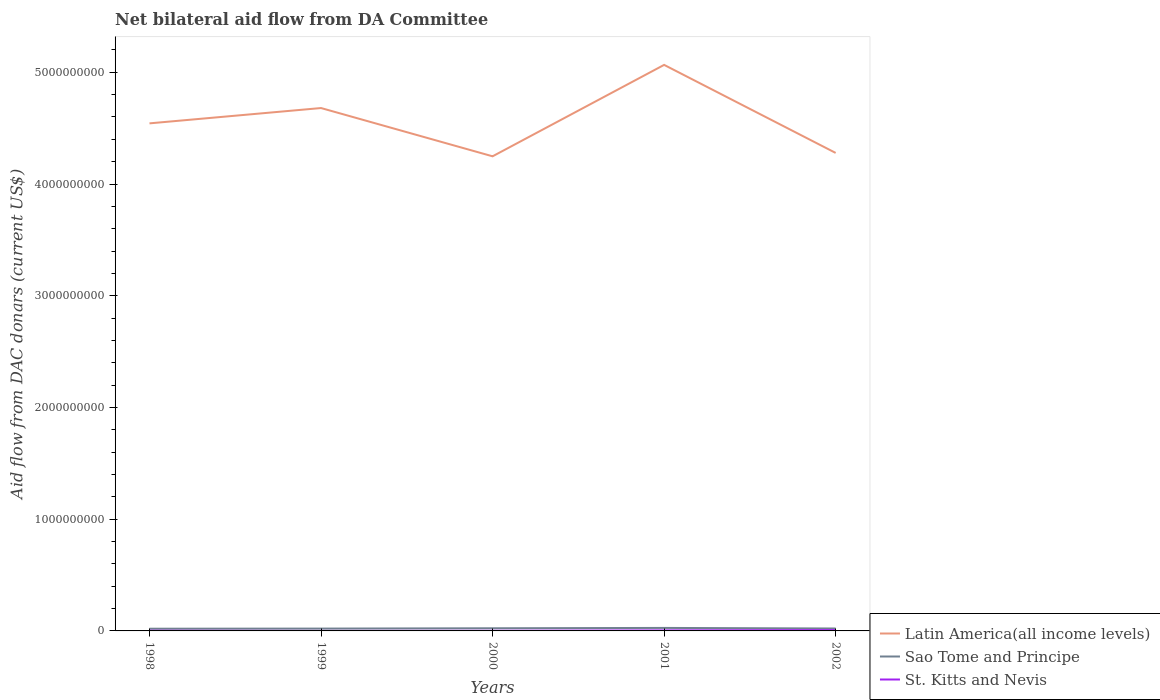How many different coloured lines are there?
Offer a very short reply. 3. Does the line corresponding to Sao Tome and Principe intersect with the line corresponding to Latin America(all income levels)?
Give a very brief answer. No. Is the number of lines equal to the number of legend labels?
Offer a terse response. Yes. Across all years, what is the maximum aid flow in in Latin America(all income levels)?
Provide a succinct answer. 4.25e+09. What is the total aid flow in in Latin America(all income levels) in the graph?
Your answer should be compact. -3.86e+08. What is the difference between the highest and the second highest aid flow in in Latin America(all income levels)?
Keep it short and to the point. 8.18e+08. How many years are there in the graph?
Provide a succinct answer. 5. What is the difference between two consecutive major ticks on the Y-axis?
Offer a terse response. 1.00e+09. Does the graph contain grids?
Provide a short and direct response. No. What is the title of the graph?
Ensure brevity in your answer.  Net bilateral aid flow from DA Committee. What is the label or title of the Y-axis?
Provide a short and direct response. Aid flow from DAC donars (current US$). What is the Aid flow from DAC donars (current US$) of Latin America(all income levels) in 1998?
Your answer should be compact. 4.54e+09. What is the Aid flow from DAC donars (current US$) of Sao Tome and Principe in 1998?
Provide a succinct answer. 1.98e+07. What is the Aid flow from DAC donars (current US$) in St. Kitts and Nevis in 1998?
Your response must be concise. 1.95e+06. What is the Aid flow from DAC donars (current US$) of Latin America(all income levels) in 1999?
Your answer should be very brief. 4.68e+09. What is the Aid flow from DAC donars (current US$) in Sao Tome and Principe in 1999?
Provide a short and direct response. 2.09e+07. What is the Aid flow from DAC donars (current US$) in St. Kitts and Nevis in 1999?
Offer a terse response. 1.70e+05. What is the Aid flow from DAC donars (current US$) of Latin America(all income levels) in 2000?
Your answer should be very brief. 4.25e+09. What is the Aid flow from DAC donars (current US$) of Sao Tome and Principe in 2000?
Ensure brevity in your answer.  2.37e+07. What is the Aid flow from DAC donars (current US$) of St. Kitts and Nevis in 2000?
Provide a succinct answer. 1.39e+06. What is the Aid flow from DAC donars (current US$) in Latin America(all income levels) in 2001?
Ensure brevity in your answer.  5.07e+09. What is the Aid flow from DAC donars (current US$) of Sao Tome and Principe in 2001?
Provide a short and direct response. 2.69e+07. What is the Aid flow from DAC donars (current US$) in St. Kitts and Nevis in 2001?
Ensure brevity in your answer.  4.81e+06. What is the Aid flow from DAC donars (current US$) of Latin America(all income levels) in 2002?
Provide a succinct answer. 4.28e+09. What is the Aid flow from DAC donars (current US$) in Sao Tome and Principe in 2002?
Provide a short and direct response. 2.16e+07. What is the Aid flow from DAC donars (current US$) of St. Kitts and Nevis in 2002?
Provide a short and direct response. 7.33e+06. Across all years, what is the maximum Aid flow from DAC donars (current US$) of Latin America(all income levels)?
Make the answer very short. 5.07e+09. Across all years, what is the maximum Aid flow from DAC donars (current US$) in Sao Tome and Principe?
Make the answer very short. 2.69e+07. Across all years, what is the maximum Aid flow from DAC donars (current US$) in St. Kitts and Nevis?
Ensure brevity in your answer.  7.33e+06. Across all years, what is the minimum Aid flow from DAC donars (current US$) of Latin America(all income levels)?
Keep it short and to the point. 4.25e+09. Across all years, what is the minimum Aid flow from DAC donars (current US$) in Sao Tome and Principe?
Offer a terse response. 1.98e+07. Across all years, what is the minimum Aid flow from DAC donars (current US$) in St. Kitts and Nevis?
Your answer should be compact. 1.70e+05. What is the total Aid flow from DAC donars (current US$) of Latin America(all income levels) in the graph?
Offer a terse response. 2.28e+1. What is the total Aid flow from DAC donars (current US$) in Sao Tome and Principe in the graph?
Your answer should be very brief. 1.13e+08. What is the total Aid flow from DAC donars (current US$) in St. Kitts and Nevis in the graph?
Make the answer very short. 1.56e+07. What is the difference between the Aid flow from DAC donars (current US$) of Latin America(all income levels) in 1998 and that in 1999?
Give a very brief answer. -1.37e+08. What is the difference between the Aid flow from DAC donars (current US$) of Sao Tome and Principe in 1998 and that in 1999?
Your response must be concise. -1.09e+06. What is the difference between the Aid flow from DAC donars (current US$) of St. Kitts and Nevis in 1998 and that in 1999?
Provide a short and direct response. 1.78e+06. What is the difference between the Aid flow from DAC donars (current US$) of Latin America(all income levels) in 1998 and that in 2000?
Provide a succinct answer. 2.95e+08. What is the difference between the Aid flow from DAC donars (current US$) of Sao Tome and Principe in 1998 and that in 2000?
Provide a short and direct response. -3.93e+06. What is the difference between the Aid flow from DAC donars (current US$) in St. Kitts and Nevis in 1998 and that in 2000?
Make the answer very short. 5.60e+05. What is the difference between the Aid flow from DAC donars (current US$) in Latin America(all income levels) in 1998 and that in 2001?
Your answer should be compact. -5.23e+08. What is the difference between the Aid flow from DAC donars (current US$) of Sao Tome and Principe in 1998 and that in 2001?
Ensure brevity in your answer.  -7.11e+06. What is the difference between the Aid flow from DAC donars (current US$) in St. Kitts and Nevis in 1998 and that in 2001?
Give a very brief answer. -2.86e+06. What is the difference between the Aid flow from DAC donars (current US$) in Latin America(all income levels) in 1998 and that in 2002?
Offer a terse response. 2.65e+08. What is the difference between the Aid flow from DAC donars (current US$) of Sao Tome and Principe in 1998 and that in 2002?
Give a very brief answer. -1.86e+06. What is the difference between the Aid flow from DAC donars (current US$) of St. Kitts and Nevis in 1998 and that in 2002?
Provide a short and direct response. -5.38e+06. What is the difference between the Aid flow from DAC donars (current US$) of Latin America(all income levels) in 1999 and that in 2000?
Provide a succinct answer. 4.32e+08. What is the difference between the Aid flow from DAC donars (current US$) in Sao Tome and Principe in 1999 and that in 2000?
Make the answer very short. -2.84e+06. What is the difference between the Aid flow from DAC donars (current US$) in St. Kitts and Nevis in 1999 and that in 2000?
Offer a very short reply. -1.22e+06. What is the difference between the Aid flow from DAC donars (current US$) in Latin America(all income levels) in 1999 and that in 2001?
Give a very brief answer. -3.86e+08. What is the difference between the Aid flow from DAC donars (current US$) in Sao Tome and Principe in 1999 and that in 2001?
Your response must be concise. -6.02e+06. What is the difference between the Aid flow from DAC donars (current US$) of St. Kitts and Nevis in 1999 and that in 2001?
Ensure brevity in your answer.  -4.64e+06. What is the difference between the Aid flow from DAC donars (current US$) in Latin America(all income levels) in 1999 and that in 2002?
Ensure brevity in your answer.  4.02e+08. What is the difference between the Aid flow from DAC donars (current US$) in Sao Tome and Principe in 1999 and that in 2002?
Your answer should be very brief. -7.70e+05. What is the difference between the Aid flow from DAC donars (current US$) of St. Kitts and Nevis in 1999 and that in 2002?
Make the answer very short. -7.16e+06. What is the difference between the Aid flow from DAC donars (current US$) in Latin America(all income levels) in 2000 and that in 2001?
Give a very brief answer. -8.18e+08. What is the difference between the Aid flow from DAC donars (current US$) of Sao Tome and Principe in 2000 and that in 2001?
Offer a very short reply. -3.18e+06. What is the difference between the Aid flow from DAC donars (current US$) of St. Kitts and Nevis in 2000 and that in 2001?
Give a very brief answer. -3.42e+06. What is the difference between the Aid flow from DAC donars (current US$) in Latin America(all income levels) in 2000 and that in 2002?
Offer a very short reply. -3.03e+07. What is the difference between the Aid flow from DAC donars (current US$) of Sao Tome and Principe in 2000 and that in 2002?
Your answer should be compact. 2.07e+06. What is the difference between the Aid flow from DAC donars (current US$) of St. Kitts and Nevis in 2000 and that in 2002?
Keep it short and to the point. -5.94e+06. What is the difference between the Aid flow from DAC donars (current US$) of Latin America(all income levels) in 2001 and that in 2002?
Provide a short and direct response. 7.88e+08. What is the difference between the Aid flow from DAC donars (current US$) of Sao Tome and Principe in 2001 and that in 2002?
Provide a short and direct response. 5.25e+06. What is the difference between the Aid flow from DAC donars (current US$) of St. Kitts and Nevis in 2001 and that in 2002?
Your answer should be very brief. -2.52e+06. What is the difference between the Aid flow from DAC donars (current US$) of Latin America(all income levels) in 1998 and the Aid flow from DAC donars (current US$) of Sao Tome and Principe in 1999?
Provide a short and direct response. 4.52e+09. What is the difference between the Aid flow from DAC donars (current US$) in Latin America(all income levels) in 1998 and the Aid flow from DAC donars (current US$) in St. Kitts and Nevis in 1999?
Ensure brevity in your answer.  4.54e+09. What is the difference between the Aid flow from DAC donars (current US$) of Sao Tome and Principe in 1998 and the Aid flow from DAC donars (current US$) of St. Kitts and Nevis in 1999?
Ensure brevity in your answer.  1.96e+07. What is the difference between the Aid flow from DAC donars (current US$) in Latin America(all income levels) in 1998 and the Aid flow from DAC donars (current US$) in Sao Tome and Principe in 2000?
Your answer should be compact. 4.52e+09. What is the difference between the Aid flow from DAC donars (current US$) in Latin America(all income levels) in 1998 and the Aid flow from DAC donars (current US$) in St. Kitts and Nevis in 2000?
Make the answer very short. 4.54e+09. What is the difference between the Aid flow from DAC donars (current US$) in Sao Tome and Principe in 1998 and the Aid flow from DAC donars (current US$) in St. Kitts and Nevis in 2000?
Your answer should be compact. 1.84e+07. What is the difference between the Aid flow from DAC donars (current US$) of Latin America(all income levels) in 1998 and the Aid flow from DAC donars (current US$) of Sao Tome and Principe in 2001?
Give a very brief answer. 4.52e+09. What is the difference between the Aid flow from DAC donars (current US$) in Latin America(all income levels) in 1998 and the Aid flow from DAC donars (current US$) in St. Kitts and Nevis in 2001?
Offer a terse response. 4.54e+09. What is the difference between the Aid flow from DAC donars (current US$) in Sao Tome and Principe in 1998 and the Aid flow from DAC donars (current US$) in St. Kitts and Nevis in 2001?
Provide a succinct answer. 1.50e+07. What is the difference between the Aid flow from DAC donars (current US$) of Latin America(all income levels) in 1998 and the Aid flow from DAC donars (current US$) of Sao Tome and Principe in 2002?
Offer a terse response. 4.52e+09. What is the difference between the Aid flow from DAC donars (current US$) of Latin America(all income levels) in 1998 and the Aid flow from DAC donars (current US$) of St. Kitts and Nevis in 2002?
Provide a short and direct response. 4.54e+09. What is the difference between the Aid flow from DAC donars (current US$) in Sao Tome and Principe in 1998 and the Aid flow from DAC donars (current US$) in St. Kitts and Nevis in 2002?
Provide a short and direct response. 1.24e+07. What is the difference between the Aid flow from DAC donars (current US$) in Latin America(all income levels) in 1999 and the Aid flow from DAC donars (current US$) in Sao Tome and Principe in 2000?
Give a very brief answer. 4.66e+09. What is the difference between the Aid flow from DAC donars (current US$) of Latin America(all income levels) in 1999 and the Aid flow from DAC donars (current US$) of St. Kitts and Nevis in 2000?
Make the answer very short. 4.68e+09. What is the difference between the Aid flow from DAC donars (current US$) of Sao Tome and Principe in 1999 and the Aid flow from DAC donars (current US$) of St. Kitts and Nevis in 2000?
Offer a very short reply. 1.95e+07. What is the difference between the Aid flow from DAC donars (current US$) of Latin America(all income levels) in 1999 and the Aid flow from DAC donars (current US$) of Sao Tome and Principe in 2001?
Your answer should be very brief. 4.65e+09. What is the difference between the Aid flow from DAC donars (current US$) of Latin America(all income levels) in 1999 and the Aid flow from DAC donars (current US$) of St. Kitts and Nevis in 2001?
Offer a very short reply. 4.68e+09. What is the difference between the Aid flow from DAC donars (current US$) of Sao Tome and Principe in 1999 and the Aid flow from DAC donars (current US$) of St. Kitts and Nevis in 2001?
Your response must be concise. 1.61e+07. What is the difference between the Aid flow from DAC donars (current US$) in Latin America(all income levels) in 1999 and the Aid flow from DAC donars (current US$) in Sao Tome and Principe in 2002?
Provide a succinct answer. 4.66e+09. What is the difference between the Aid flow from DAC donars (current US$) of Latin America(all income levels) in 1999 and the Aid flow from DAC donars (current US$) of St. Kitts and Nevis in 2002?
Offer a very short reply. 4.67e+09. What is the difference between the Aid flow from DAC donars (current US$) of Sao Tome and Principe in 1999 and the Aid flow from DAC donars (current US$) of St. Kitts and Nevis in 2002?
Provide a succinct answer. 1.35e+07. What is the difference between the Aid flow from DAC donars (current US$) in Latin America(all income levels) in 2000 and the Aid flow from DAC donars (current US$) in Sao Tome and Principe in 2001?
Keep it short and to the point. 4.22e+09. What is the difference between the Aid flow from DAC donars (current US$) in Latin America(all income levels) in 2000 and the Aid flow from DAC donars (current US$) in St. Kitts and Nevis in 2001?
Your response must be concise. 4.24e+09. What is the difference between the Aid flow from DAC donars (current US$) in Sao Tome and Principe in 2000 and the Aid flow from DAC donars (current US$) in St. Kitts and Nevis in 2001?
Make the answer very short. 1.89e+07. What is the difference between the Aid flow from DAC donars (current US$) of Latin America(all income levels) in 2000 and the Aid flow from DAC donars (current US$) of Sao Tome and Principe in 2002?
Make the answer very short. 4.23e+09. What is the difference between the Aid flow from DAC donars (current US$) of Latin America(all income levels) in 2000 and the Aid flow from DAC donars (current US$) of St. Kitts and Nevis in 2002?
Offer a terse response. 4.24e+09. What is the difference between the Aid flow from DAC donars (current US$) of Sao Tome and Principe in 2000 and the Aid flow from DAC donars (current US$) of St. Kitts and Nevis in 2002?
Your answer should be compact. 1.64e+07. What is the difference between the Aid flow from DAC donars (current US$) of Latin America(all income levels) in 2001 and the Aid flow from DAC donars (current US$) of Sao Tome and Principe in 2002?
Your answer should be compact. 5.04e+09. What is the difference between the Aid flow from DAC donars (current US$) in Latin America(all income levels) in 2001 and the Aid flow from DAC donars (current US$) in St. Kitts and Nevis in 2002?
Your response must be concise. 5.06e+09. What is the difference between the Aid flow from DAC donars (current US$) in Sao Tome and Principe in 2001 and the Aid flow from DAC donars (current US$) in St. Kitts and Nevis in 2002?
Keep it short and to the point. 1.96e+07. What is the average Aid flow from DAC donars (current US$) of Latin America(all income levels) per year?
Your answer should be very brief. 4.56e+09. What is the average Aid flow from DAC donars (current US$) of Sao Tome and Principe per year?
Ensure brevity in your answer.  2.26e+07. What is the average Aid flow from DAC donars (current US$) in St. Kitts and Nevis per year?
Ensure brevity in your answer.  3.13e+06. In the year 1998, what is the difference between the Aid flow from DAC donars (current US$) in Latin America(all income levels) and Aid flow from DAC donars (current US$) in Sao Tome and Principe?
Ensure brevity in your answer.  4.52e+09. In the year 1998, what is the difference between the Aid flow from DAC donars (current US$) in Latin America(all income levels) and Aid flow from DAC donars (current US$) in St. Kitts and Nevis?
Keep it short and to the point. 4.54e+09. In the year 1998, what is the difference between the Aid flow from DAC donars (current US$) of Sao Tome and Principe and Aid flow from DAC donars (current US$) of St. Kitts and Nevis?
Provide a succinct answer. 1.78e+07. In the year 1999, what is the difference between the Aid flow from DAC donars (current US$) in Latin America(all income levels) and Aid flow from DAC donars (current US$) in Sao Tome and Principe?
Offer a terse response. 4.66e+09. In the year 1999, what is the difference between the Aid flow from DAC donars (current US$) of Latin America(all income levels) and Aid flow from DAC donars (current US$) of St. Kitts and Nevis?
Provide a short and direct response. 4.68e+09. In the year 1999, what is the difference between the Aid flow from DAC donars (current US$) of Sao Tome and Principe and Aid flow from DAC donars (current US$) of St. Kitts and Nevis?
Offer a very short reply. 2.07e+07. In the year 2000, what is the difference between the Aid flow from DAC donars (current US$) of Latin America(all income levels) and Aid flow from DAC donars (current US$) of Sao Tome and Principe?
Your response must be concise. 4.22e+09. In the year 2000, what is the difference between the Aid flow from DAC donars (current US$) of Latin America(all income levels) and Aid flow from DAC donars (current US$) of St. Kitts and Nevis?
Your answer should be compact. 4.25e+09. In the year 2000, what is the difference between the Aid flow from DAC donars (current US$) of Sao Tome and Principe and Aid flow from DAC donars (current US$) of St. Kitts and Nevis?
Ensure brevity in your answer.  2.23e+07. In the year 2001, what is the difference between the Aid flow from DAC donars (current US$) of Latin America(all income levels) and Aid flow from DAC donars (current US$) of Sao Tome and Principe?
Your response must be concise. 5.04e+09. In the year 2001, what is the difference between the Aid flow from DAC donars (current US$) in Latin America(all income levels) and Aid flow from DAC donars (current US$) in St. Kitts and Nevis?
Provide a short and direct response. 5.06e+09. In the year 2001, what is the difference between the Aid flow from DAC donars (current US$) in Sao Tome and Principe and Aid flow from DAC donars (current US$) in St. Kitts and Nevis?
Give a very brief answer. 2.21e+07. In the year 2002, what is the difference between the Aid flow from DAC donars (current US$) in Latin America(all income levels) and Aid flow from DAC donars (current US$) in Sao Tome and Principe?
Your answer should be very brief. 4.26e+09. In the year 2002, what is the difference between the Aid flow from DAC donars (current US$) of Latin America(all income levels) and Aid flow from DAC donars (current US$) of St. Kitts and Nevis?
Your response must be concise. 4.27e+09. In the year 2002, what is the difference between the Aid flow from DAC donars (current US$) of Sao Tome and Principe and Aid flow from DAC donars (current US$) of St. Kitts and Nevis?
Your answer should be compact. 1.43e+07. What is the ratio of the Aid flow from DAC donars (current US$) of Latin America(all income levels) in 1998 to that in 1999?
Your response must be concise. 0.97. What is the ratio of the Aid flow from DAC donars (current US$) in Sao Tome and Principe in 1998 to that in 1999?
Offer a very short reply. 0.95. What is the ratio of the Aid flow from DAC donars (current US$) in St. Kitts and Nevis in 1998 to that in 1999?
Offer a terse response. 11.47. What is the ratio of the Aid flow from DAC donars (current US$) of Latin America(all income levels) in 1998 to that in 2000?
Offer a very short reply. 1.07. What is the ratio of the Aid flow from DAC donars (current US$) of Sao Tome and Principe in 1998 to that in 2000?
Offer a terse response. 0.83. What is the ratio of the Aid flow from DAC donars (current US$) of St. Kitts and Nevis in 1998 to that in 2000?
Offer a very short reply. 1.4. What is the ratio of the Aid flow from DAC donars (current US$) in Latin America(all income levels) in 1998 to that in 2001?
Keep it short and to the point. 0.9. What is the ratio of the Aid flow from DAC donars (current US$) in Sao Tome and Principe in 1998 to that in 2001?
Keep it short and to the point. 0.74. What is the ratio of the Aid flow from DAC donars (current US$) in St. Kitts and Nevis in 1998 to that in 2001?
Offer a very short reply. 0.41. What is the ratio of the Aid flow from DAC donars (current US$) of Latin America(all income levels) in 1998 to that in 2002?
Make the answer very short. 1.06. What is the ratio of the Aid flow from DAC donars (current US$) in Sao Tome and Principe in 1998 to that in 2002?
Make the answer very short. 0.91. What is the ratio of the Aid flow from DAC donars (current US$) in St. Kitts and Nevis in 1998 to that in 2002?
Keep it short and to the point. 0.27. What is the ratio of the Aid flow from DAC donars (current US$) in Latin America(all income levels) in 1999 to that in 2000?
Your answer should be compact. 1.1. What is the ratio of the Aid flow from DAC donars (current US$) of Sao Tome and Principe in 1999 to that in 2000?
Your answer should be very brief. 0.88. What is the ratio of the Aid flow from DAC donars (current US$) of St. Kitts and Nevis in 1999 to that in 2000?
Offer a terse response. 0.12. What is the ratio of the Aid flow from DAC donars (current US$) in Latin America(all income levels) in 1999 to that in 2001?
Offer a terse response. 0.92. What is the ratio of the Aid flow from DAC donars (current US$) of Sao Tome and Principe in 1999 to that in 2001?
Offer a terse response. 0.78. What is the ratio of the Aid flow from DAC donars (current US$) in St. Kitts and Nevis in 1999 to that in 2001?
Offer a very short reply. 0.04. What is the ratio of the Aid flow from DAC donars (current US$) in Latin America(all income levels) in 1999 to that in 2002?
Offer a terse response. 1.09. What is the ratio of the Aid flow from DAC donars (current US$) of Sao Tome and Principe in 1999 to that in 2002?
Your answer should be compact. 0.96. What is the ratio of the Aid flow from DAC donars (current US$) of St. Kitts and Nevis in 1999 to that in 2002?
Make the answer very short. 0.02. What is the ratio of the Aid flow from DAC donars (current US$) in Latin America(all income levels) in 2000 to that in 2001?
Provide a short and direct response. 0.84. What is the ratio of the Aid flow from DAC donars (current US$) of Sao Tome and Principe in 2000 to that in 2001?
Offer a very short reply. 0.88. What is the ratio of the Aid flow from DAC donars (current US$) of St. Kitts and Nevis in 2000 to that in 2001?
Make the answer very short. 0.29. What is the ratio of the Aid flow from DAC donars (current US$) in Latin America(all income levels) in 2000 to that in 2002?
Ensure brevity in your answer.  0.99. What is the ratio of the Aid flow from DAC donars (current US$) of Sao Tome and Principe in 2000 to that in 2002?
Make the answer very short. 1.1. What is the ratio of the Aid flow from DAC donars (current US$) in St. Kitts and Nevis in 2000 to that in 2002?
Make the answer very short. 0.19. What is the ratio of the Aid flow from DAC donars (current US$) in Latin America(all income levels) in 2001 to that in 2002?
Keep it short and to the point. 1.18. What is the ratio of the Aid flow from DAC donars (current US$) in Sao Tome and Principe in 2001 to that in 2002?
Provide a short and direct response. 1.24. What is the ratio of the Aid flow from DAC donars (current US$) of St. Kitts and Nevis in 2001 to that in 2002?
Provide a short and direct response. 0.66. What is the difference between the highest and the second highest Aid flow from DAC donars (current US$) in Latin America(all income levels)?
Keep it short and to the point. 3.86e+08. What is the difference between the highest and the second highest Aid flow from DAC donars (current US$) in Sao Tome and Principe?
Ensure brevity in your answer.  3.18e+06. What is the difference between the highest and the second highest Aid flow from DAC donars (current US$) of St. Kitts and Nevis?
Provide a succinct answer. 2.52e+06. What is the difference between the highest and the lowest Aid flow from DAC donars (current US$) in Latin America(all income levels)?
Keep it short and to the point. 8.18e+08. What is the difference between the highest and the lowest Aid flow from DAC donars (current US$) in Sao Tome and Principe?
Your response must be concise. 7.11e+06. What is the difference between the highest and the lowest Aid flow from DAC donars (current US$) of St. Kitts and Nevis?
Your answer should be compact. 7.16e+06. 